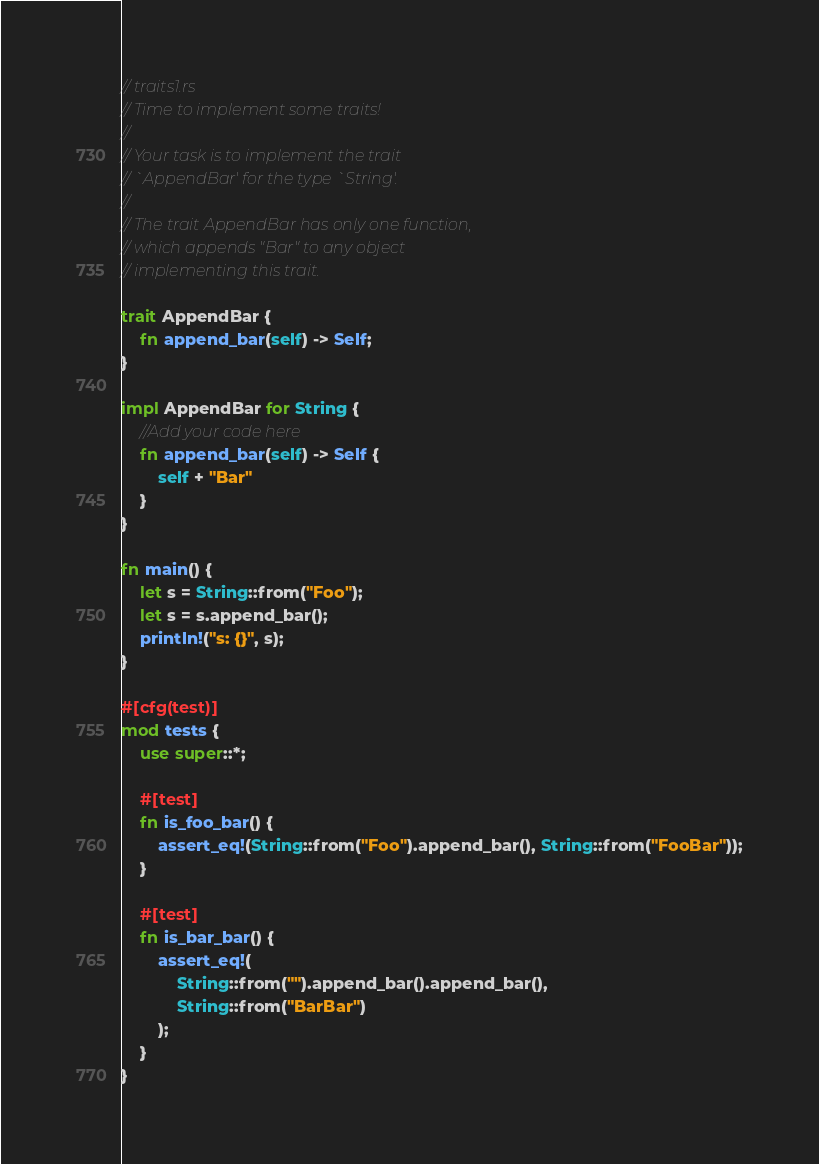Convert code to text. <code><loc_0><loc_0><loc_500><loc_500><_Rust_>// traits1.rs
// Time to implement some traits!
//
// Your task is to implement the trait
// `AppendBar' for the type `String'.
//
// The trait AppendBar has only one function,
// which appends "Bar" to any object
// implementing this trait.

trait AppendBar {
    fn append_bar(self) -> Self;
}

impl AppendBar for String {
    //Add your code here
    fn append_bar(self) -> Self {
        self + "Bar"
    }
}

fn main() {
    let s = String::from("Foo");
    let s = s.append_bar();
    println!("s: {}", s);
}

#[cfg(test)]
mod tests {
    use super::*;

    #[test]
    fn is_foo_bar() {
        assert_eq!(String::from("Foo").append_bar(), String::from("FooBar"));
    }

    #[test]
    fn is_bar_bar() {
        assert_eq!(
            String::from("").append_bar().append_bar(),
            String::from("BarBar")
        );
    }
}
</code> 